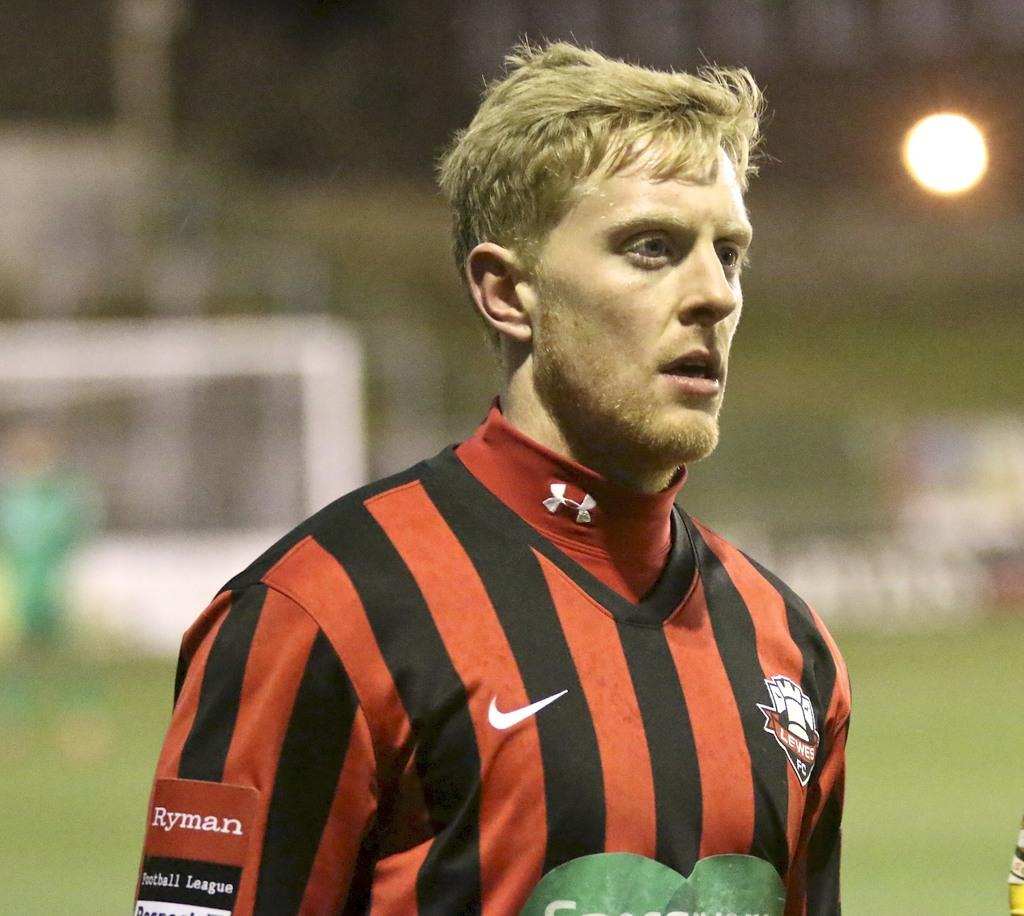What is the main subject of the image? There is a man standing in the image. What is the ground surface like in the image? The ground is covered with grass. Can you describe the background of the image? The background of the image is blurred, and there is light visible. What type of stove can be seen in the background of the image? There is no stove present in the image. Can you provide a suggestion for the man in the image? We cannot provide a suggestion for the man in the image, as we are only describing the image and not offering advice. 